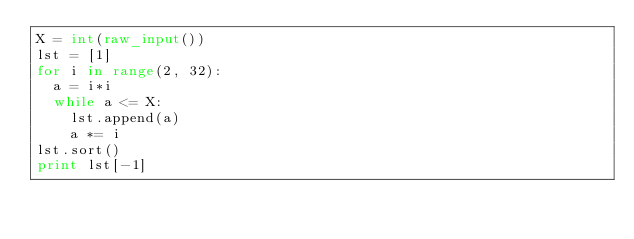Convert code to text. <code><loc_0><loc_0><loc_500><loc_500><_Python_>X = int(raw_input())
lst = [1]
for i in range(2, 32):
	a = i*i
	while a <= X:
		lst.append(a)
		a *= i
lst.sort()
print lst[-1]</code> 